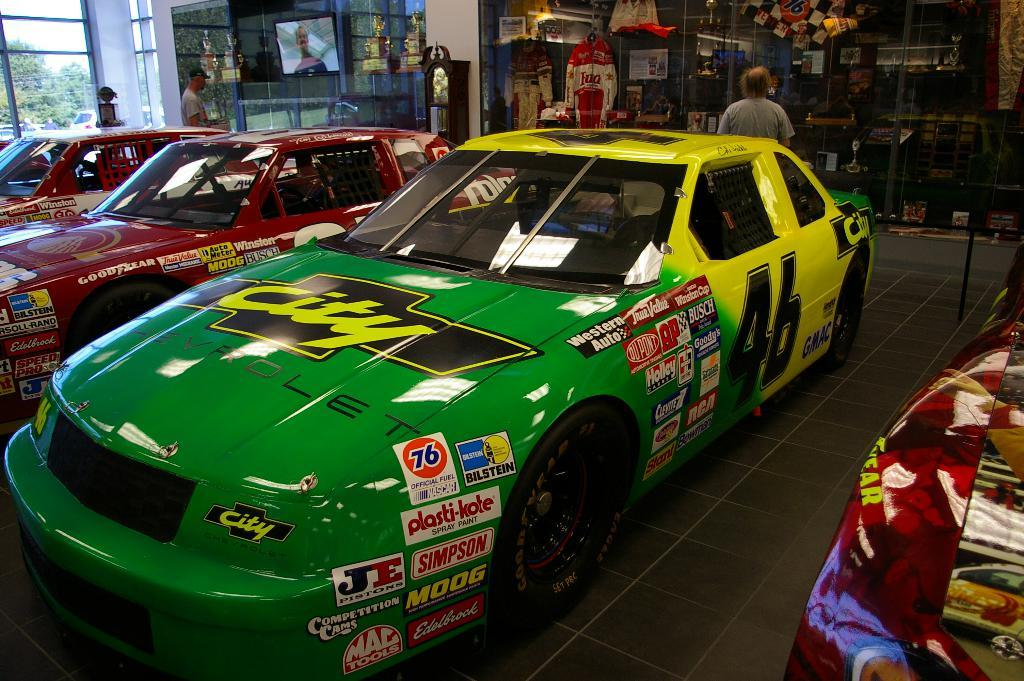<image>
Render a clear and concise summary of the photo. A green and yellow City race car is featured in a row of race cars inside a building. 